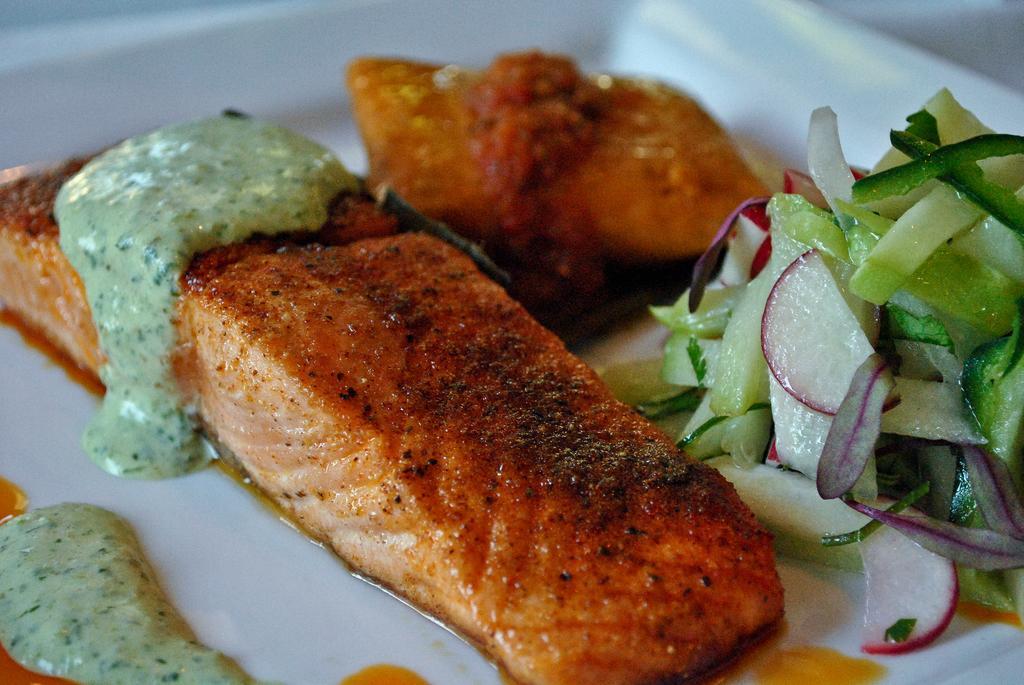In one or two sentences, can you explain what this image depicts? The picture consists of a dish served in a plate. 